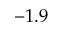<formula> <loc_0><loc_0><loc_500><loc_500>- 1 . 9</formula> 